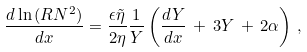Convert formula to latex. <formula><loc_0><loc_0><loc_500><loc_500>\frac { d \ln { ( R N ^ { 2 } ) } } { d x } = \frac { \epsilon \tilde { \eta } } { 2 \eta } \frac { 1 } { Y } \left ( \frac { d Y } { d x } \, + \, 3 Y \, + \, 2 \alpha \right ) \, ,</formula> 